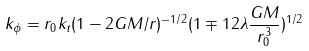<formula> <loc_0><loc_0><loc_500><loc_500>k _ { \phi } = r _ { 0 } k _ { t } ( 1 - 2 G M / r ) ^ { - 1 / 2 } ( 1 \mp 1 2 \lambda \frac { G M } { r _ { 0 } ^ { 3 } } ) ^ { 1 / 2 }</formula> 